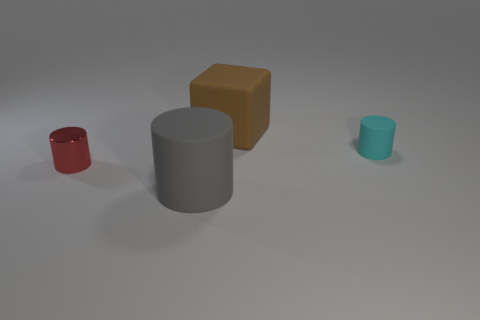Are there any other things that have the same material as the red thing?
Offer a terse response. No. What color is the cylinder that is the same size as the brown rubber thing?
Offer a terse response. Gray. Is the large object in front of the tiny cyan cylinder made of the same material as the red thing?
Provide a short and direct response. No. What is the size of the matte object that is both to the left of the cyan cylinder and behind the small red metallic thing?
Your response must be concise. Large. There is a rubber cylinder that is behind the tiny red shiny cylinder; what size is it?
Ensure brevity in your answer.  Small. The small object that is in front of the tiny object behind the small object that is to the left of the large cylinder is what shape?
Your answer should be very brief. Cylinder. How many other objects are the same shape as the red metal object?
Ensure brevity in your answer.  2. How many metallic objects are either big gray cylinders or cyan cylinders?
Make the answer very short. 0. There is a small cyan cylinder that is in front of the thing that is behind the cyan cylinder; what is its material?
Offer a very short reply. Rubber. Is the number of cubes to the left of the small rubber thing greater than the number of purple metal balls?
Offer a very short reply. Yes. 